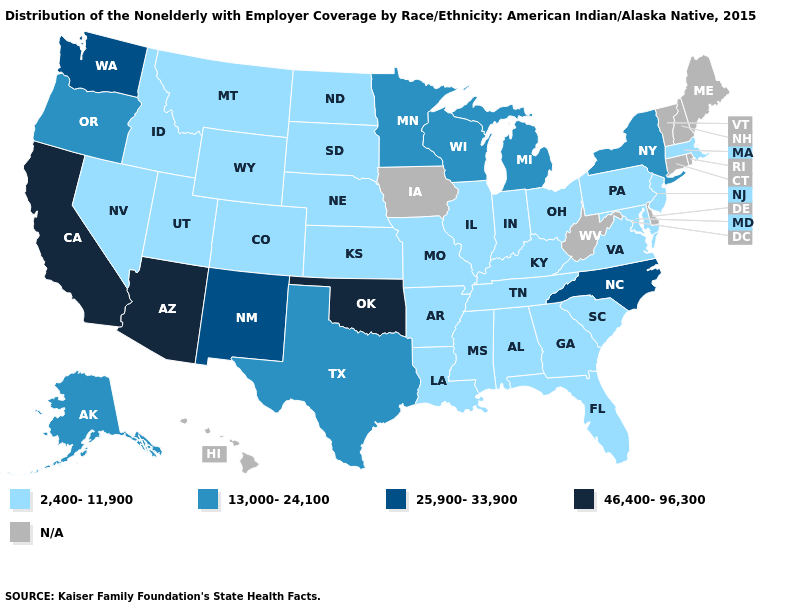Does the first symbol in the legend represent the smallest category?
Short answer required. Yes. Which states hav the highest value in the West?
Quick response, please. Arizona, California. What is the lowest value in the USA?
Be succinct. 2,400-11,900. What is the value of Vermont?
Give a very brief answer. N/A. Which states have the lowest value in the MidWest?
Quick response, please. Illinois, Indiana, Kansas, Missouri, Nebraska, North Dakota, Ohio, South Dakota. What is the lowest value in the West?
Answer briefly. 2,400-11,900. Does the map have missing data?
Keep it brief. Yes. What is the lowest value in states that border Nevada?
Write a very short answer. 2,400-11,900. What is the highest value in the USA?
Quick response, please. 46,400-96,300. Name the states that have a value in the range 46,400-96,300?
Answer briefly. Arizona, California, Oklahoma. Name the states that have a value in the range 46,400-96,300?
Be succinct. Arizona, California, Oklahoma. Name the states that have a value in the range 46,400-96,300?
Answer briefly. Arizona, California, Oklahoma. Does the map have missing data?
Write a very short answer. Yes. Name the states that have a value in the range 25,900-33,900?
Concise answer only. New Mexico, North Carolina, Washington. Does Nevada have the lowest value in the USA?
Short answer required. Yes. 